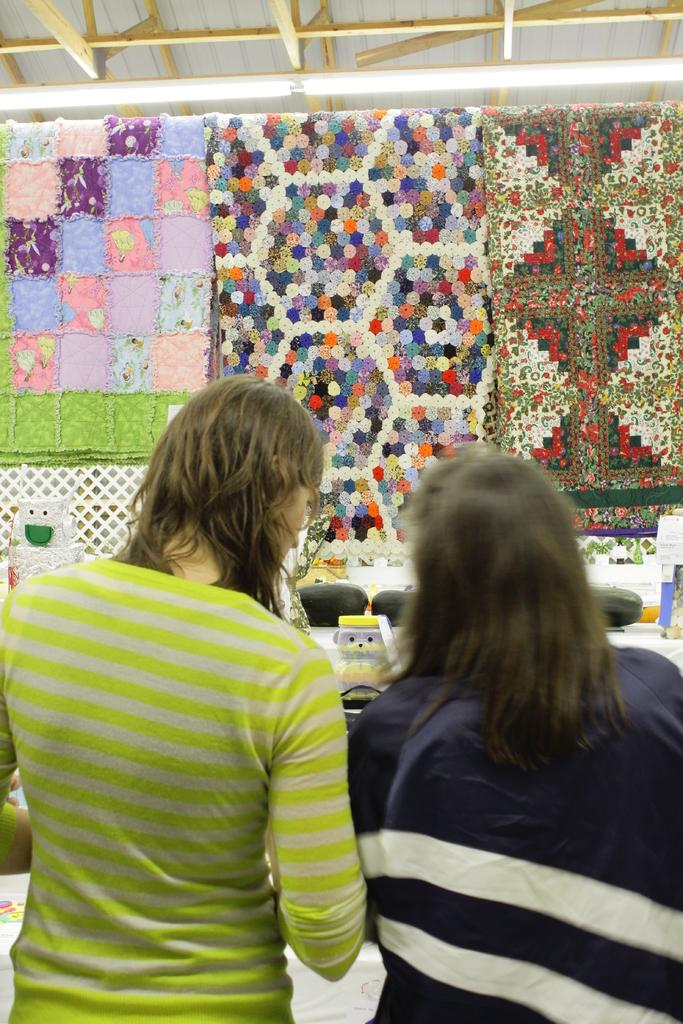How many people are in the image? There are two persons standing in the center of the image. What can be seen in the background of the image? There is a roof, a table, a fence, toys, patchwork blankets, and other objects in the background of the image. Can you describe the objects in the background of the image? The objects in the background include a table, a fence, toys, and patchwork blankets. How many parcels are being delivered to the persons in the image? There is no mention of any parcels being delivered in the image. What type of boundary is visible in the image? There is no specific boundary visible in the image; only a fence can be seen in the background. 